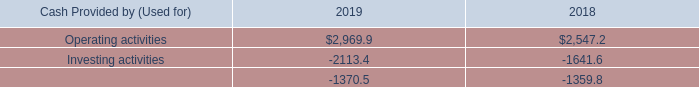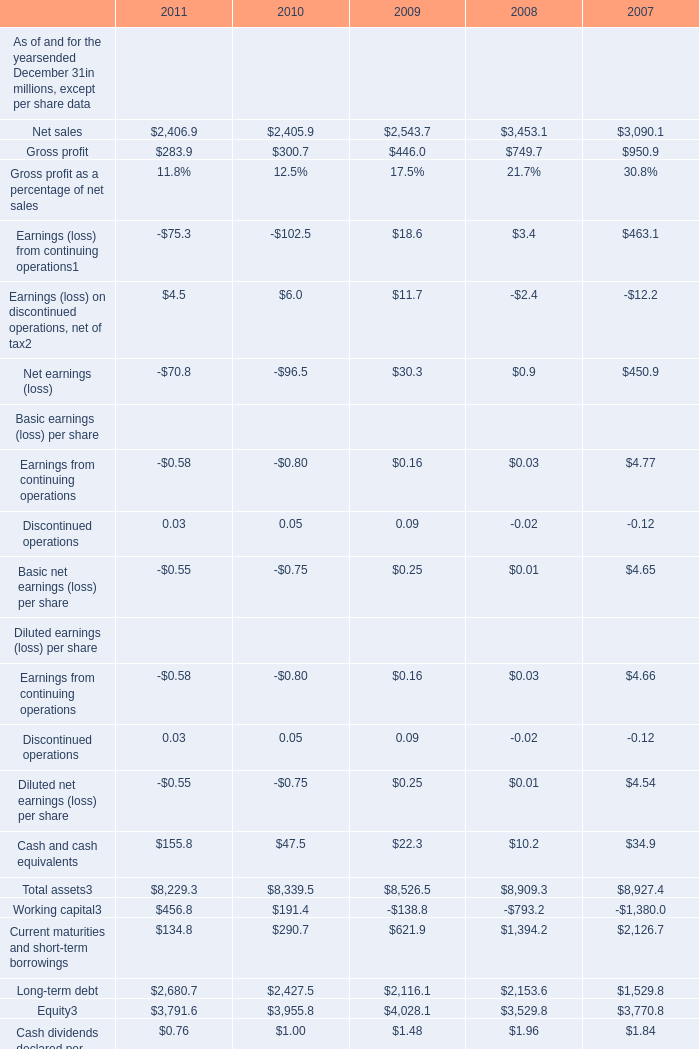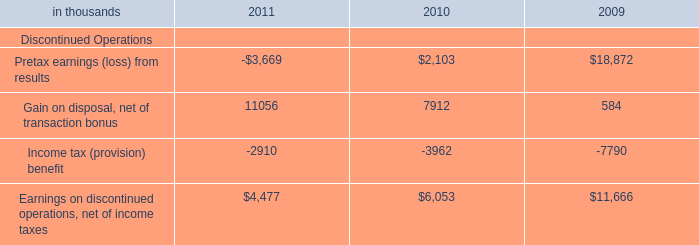"What is the difference between the greatest Gross profit in 2011 and 2010? (in million) 
Computations: (300.7 - 283.9)
Answer: 16.8. 